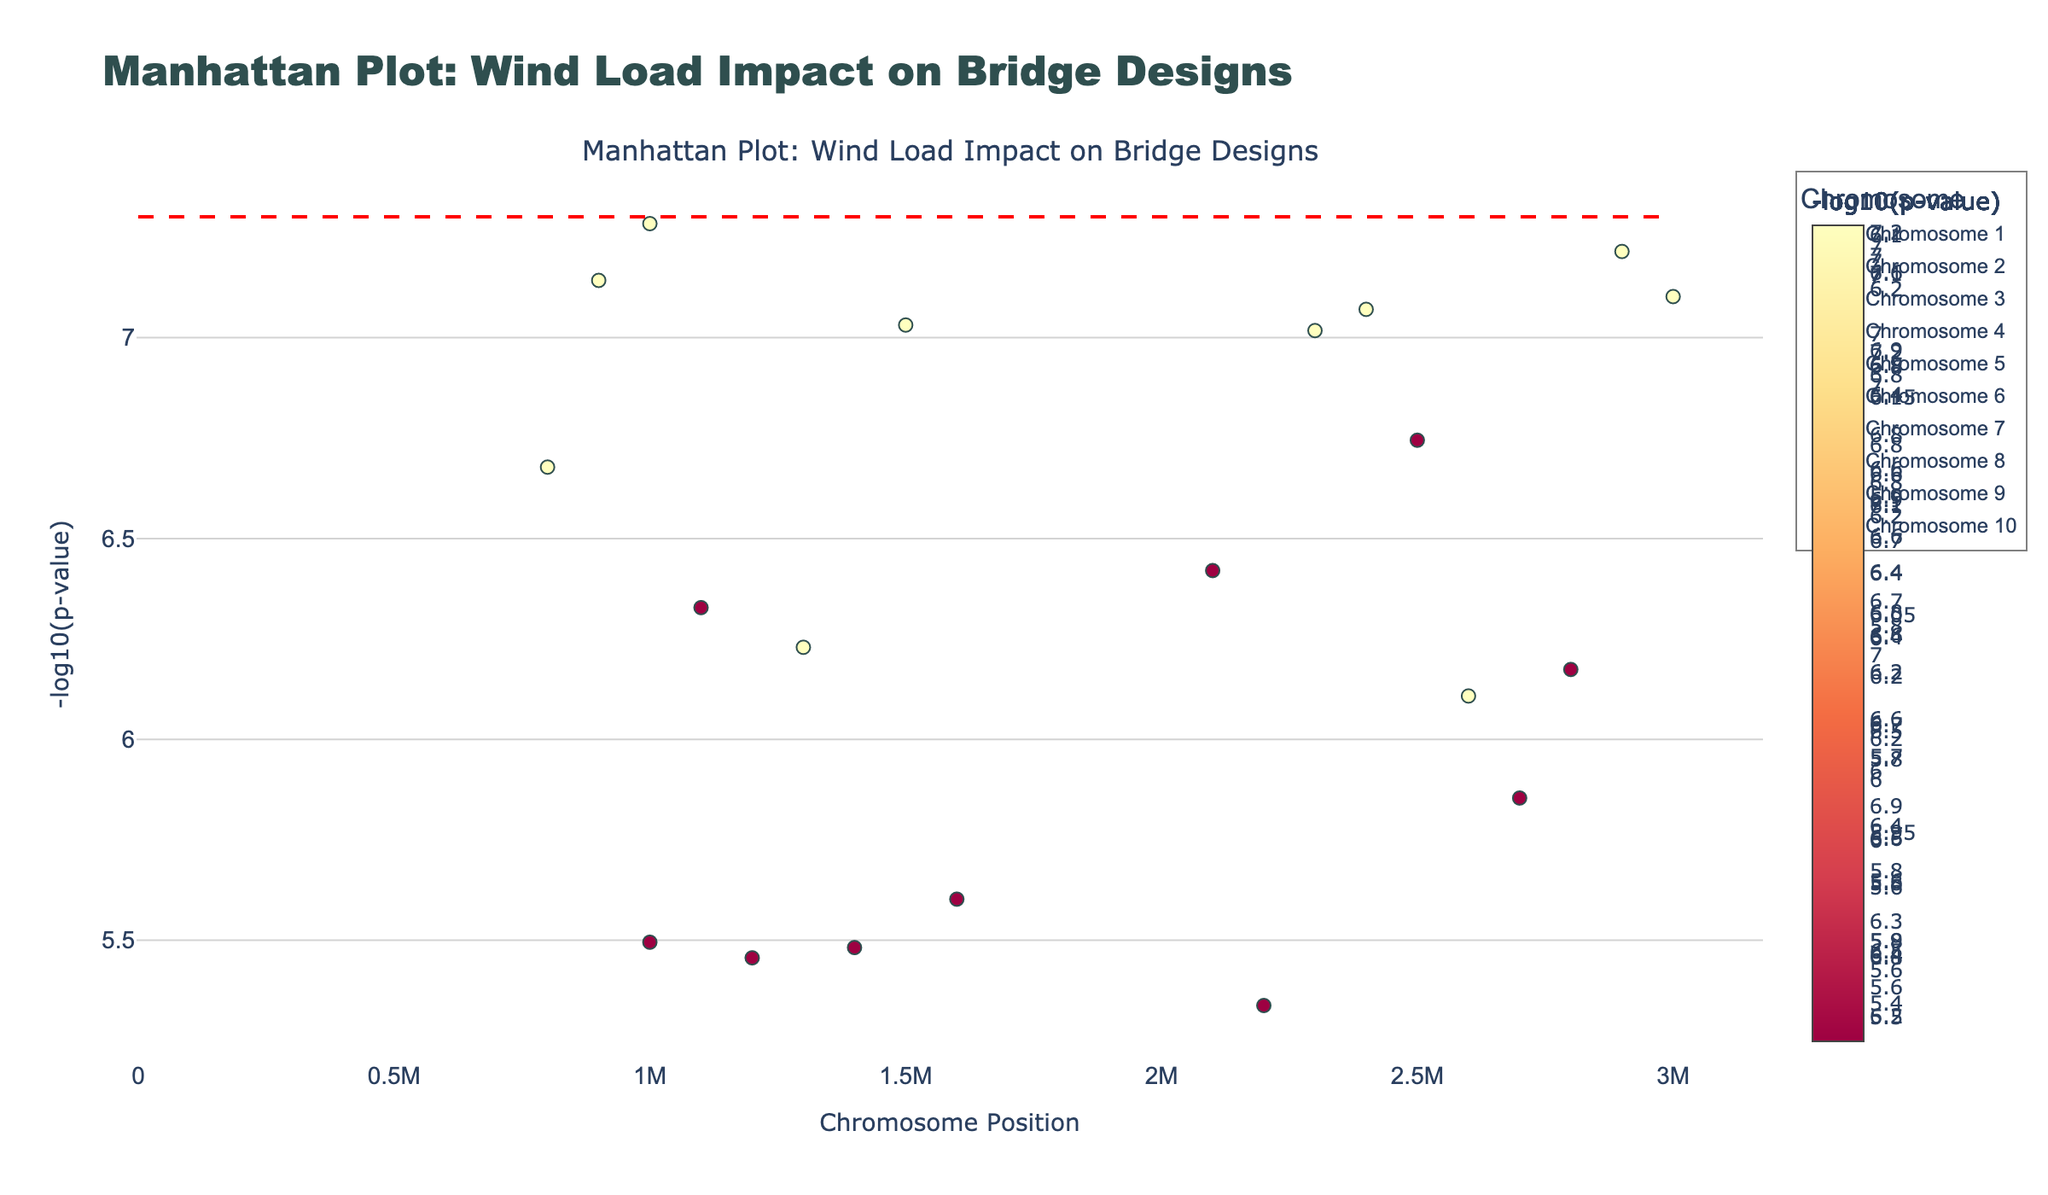Which chromosome has the highest -log10(p-value)? The highest -log10(p-value) is a measure of the smallest p-value, represented by the highest point on the y-axis. By examining the plot, identify which chromosome this point belongs to.
Answer: Chromosome 1 What is the position of the highest peak in Chromosome 4? Locate Chromosome 4 on the plot and find the highest peak, the y-axis value for this peak should be the highest. Then, trace it back to the corresponding x-axis value, which represents the position.
Answer: 1,500,000 Which bridge design has the lowest p-value in Chromosome 3? For Chromosome 3, find the highest marker on the plot. Hover over it to read the information that includes the bridge design and the associated p-value. The design with the highest marker on Chromosome 3 corresponds to the lowest p-value.
Answer: Beam How many chromosomes have at least one data point above the significance line? Identify the chromosomes with markers above the red significance line. Count the number of these chromosomes.
Answer: 10 Which geographical location shows the most significant p-value? The most significant p-value is the lowest p-value, which corresponds to the highest -log10(p-value). Identify the highest point on the plot and read the geographical location from the hover information.
Answer: San Francisco How does the -log10(p-value) of the most significant point in Chromosome 2 compare with that in Chromosome 7? Determine the -log10(p-value) for the highest points in Chromosome 2 and Chromosome 7 by examining the y-axis values. Compare these values to see which is higher.
Answer: Chromosome 2 has a higher -log10(p-value) Is there a significant difference in the number of peaks above the significance line between Chromosome 1 and Chromosome 9? Count the number of peaks above the significance line for Chromosome 1 and Chromosome 9. Compare these counts to determine if there is a significant difference.
Answer: Yes, Chromosome 1 has more significant peaks Which bridge design in Chromosome 5 is associated with the highest -log10(p-value)? Examine Chromosome 5 and find the highest marker. Hover over it to find the associated bridge design.
Answer: Suspension Out of the locations listed, which one has the highest -log10(p-value) for a Truss bridge design? Identify all the points corresponding to the Truss bridge design on the plot. Compare their -log10(p-value) values and find the highest one. Then, read the geographical location from the hover information.
Answer: Chicago How many bridge designs were evaluated across all chromosomes? Each data point corresponds to one bridge design in a specific location. Count the unique bridge designs across all chromosomes by examining the annotations or hover information.
Answer: 10 